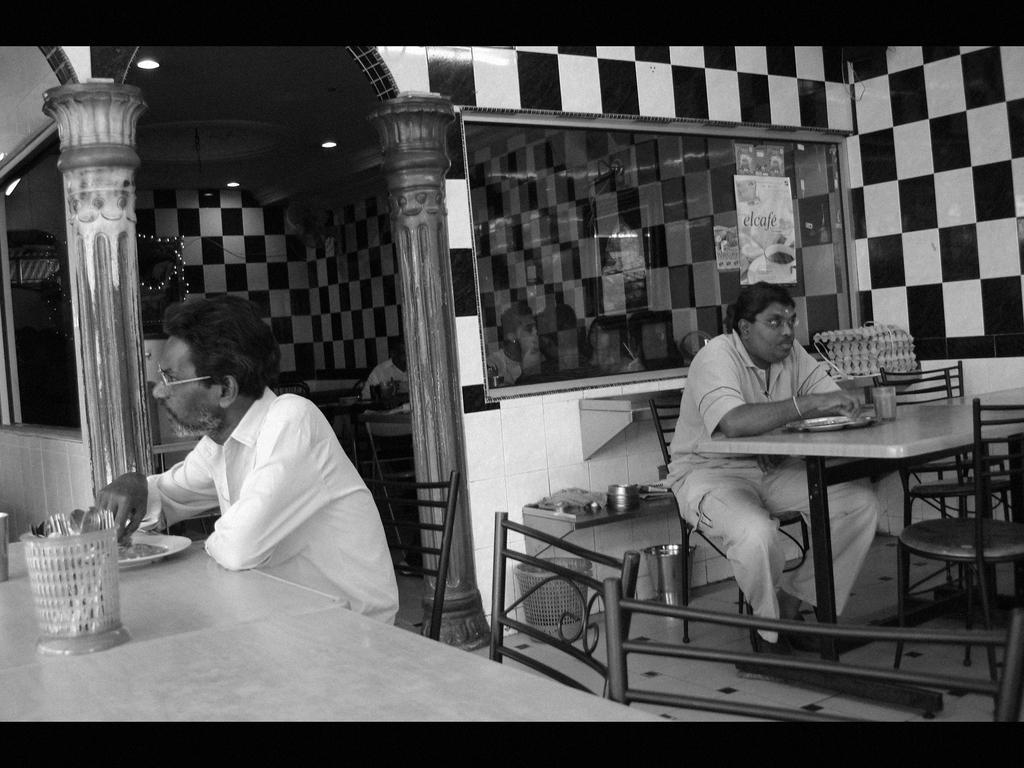Could you give a brief overview of what you see in this image? In this edited image, we can see some chairs and tables. There are two persons in the middle of the image, sitting in front of plates and glasses. There is a spoon holder in the bottom left of the image. There are pillars beside the window. There is an object on the right side of the image. There is a bin and bucket at the bottom of the image. There are lights in the top left of the image. 